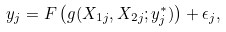<formula> <loc_0><loc_0><loc_500><loc_500>y _ { j } = F \left ( g ( X _ { 1 j } , X _ { 2 j } ; y ^ { * } _ { j } ) \right ) + \epsilon _ { j } ,</formula> 